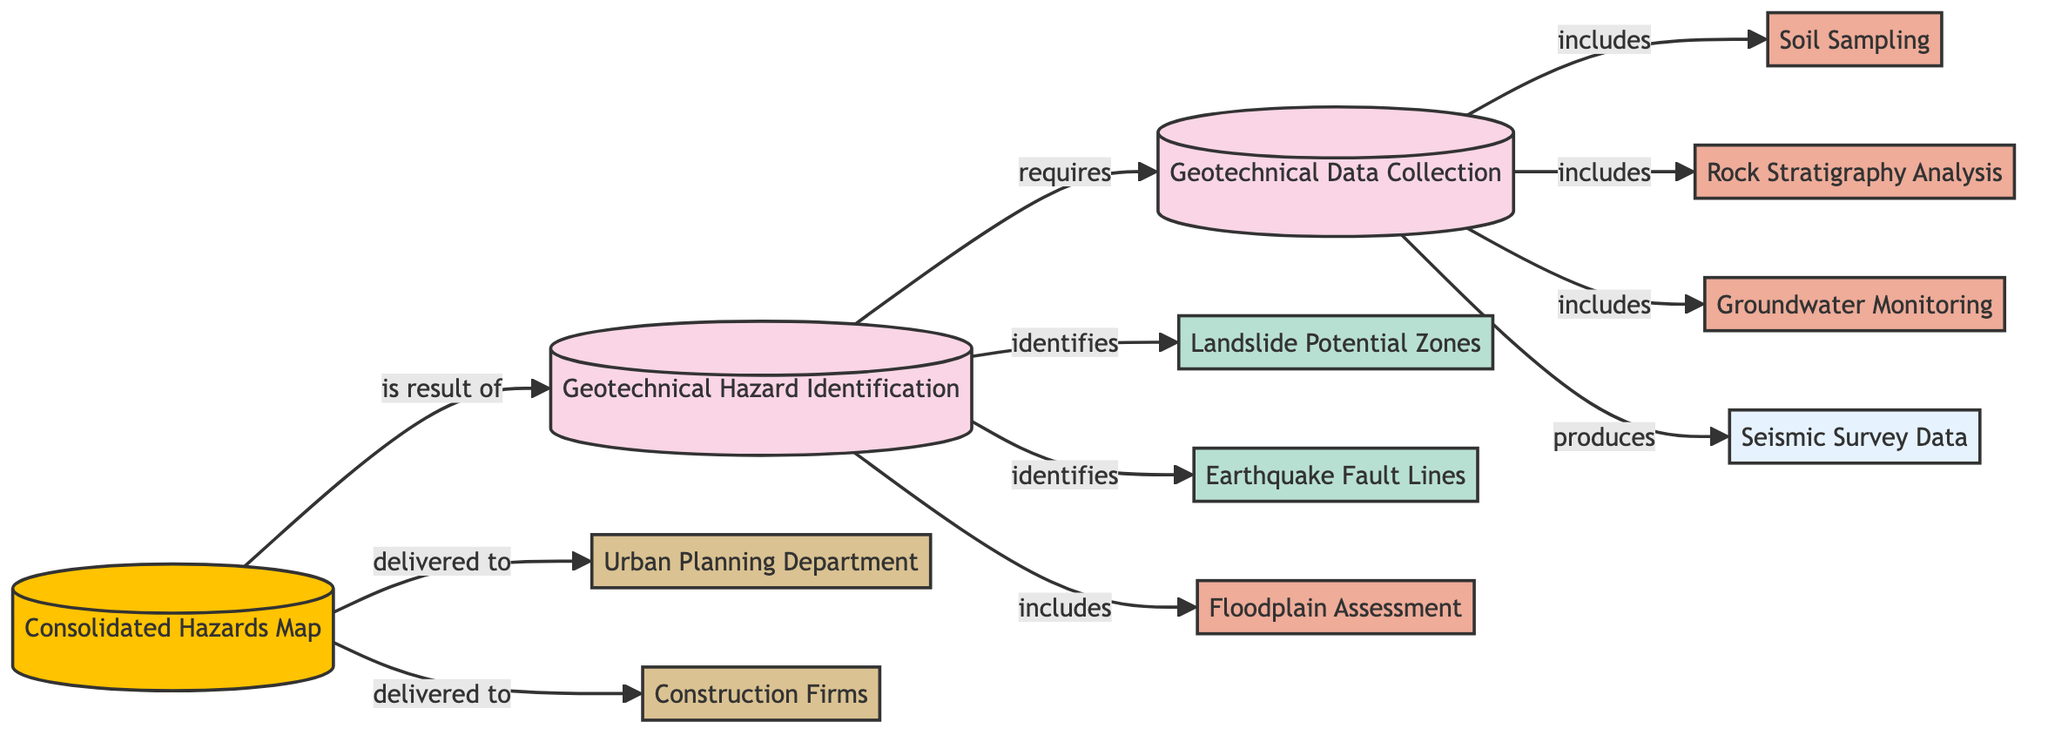What is the total number of nodes in the diagram? The diagram lists 12 distinct nodes including processes, activities, data, geological features, output, and stakeholders.
Answer: 12 What type of relationship exists between "Geotechnical Data Collection" and "Soil Sampling"? The diagram shows the relationship labeled as "includes" between these two nodes, indicating that "Geotechnical Data Collection" encompasses "Soil Sampling."
Answer: includes Which node produces "Seismic Survey Data"? The "Geotechnical Data Collection" node is responsible for producing "Seismic Survey Data," as indicated by the arrow labeled "produces."
Answer: Geotechnical Data Collection How many geological features are identified in the diagram? There are two geological features identified: "Landslide Potential Zones" and "Earthquake Fault Lines," connected to the "Geotechnical Hazard Identification" node.
Answer: 2 Which stakeholder receives the "Consolidated Hazards Map"? Both the "Urban Planning Department" and "Construction Firms" are the stakeholders that receive the "Consolidated Hazards Map," as shown by the arrows pointing to these nodes from the output.
Answer: Urban Planning Department, Construction Firms What is a required process for "Geotechnical Hazard Identification"? The "Geotechnical Data Collection" is required for "Geotechnical Hazard Identification," indicating that data collection is essential for this identification process.
Answer: Geotechnical Data Collection Why is "Groundwater Monitoring" included in the "Geotechnical Data Collection"? "Groundwater Monitoring" is part of the activities that inform the geotechnical data collection process, as shown by the "includes" relationship connecting the two.
Answer: Geotechnical Data Collection What is the purpose of the "Consolidated Hazards Map"? The "Consolidated Hazards Map" serves as the output of the "Geotechnical Hazard Identification" process, summarizing identified hazards for usage by stakeholders.
Answer: is result of What type of node is "Earthquake Fault Lines"? This is categorized as a "Geological Feature," as indicated in the diagram's structure and classifications shown for each node.
Answer: Geological Feature 